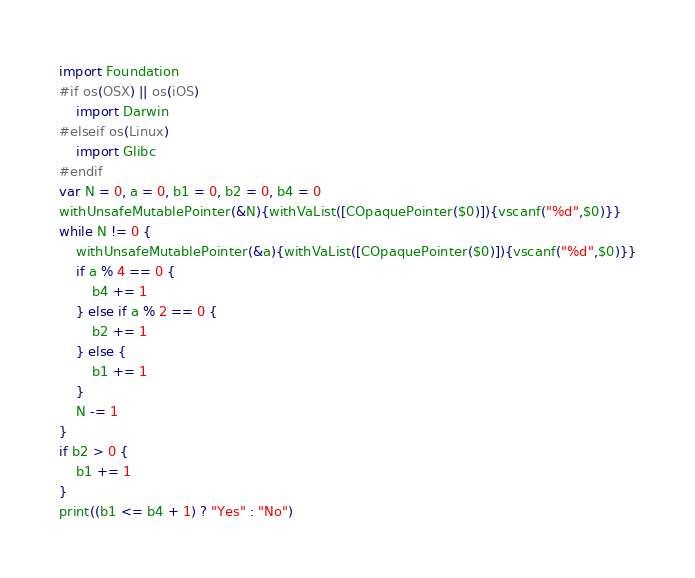<code> <loc_0><loc_0><loc_500><loc_500><_Swift_>import Foundation
#if os(OSX) || os(iOS)
    import Darwin
#elseif os(Linux)
    import Glibc
#endif
var N = 0, a = 0, b1 = 0, b2 = 0, b4 = 0
withUnsafeMutablePointer(&N){withVaList([COpaquePointer($0)]){vscanf("%d",$0)}}
while N != 0 {
    withUnsafeMutablePointer(&a){withVaList([COpaquePointer($0)]){vscanf("%d",$0)}}
    if a % 4 == 0 {
        b4 += 1
    } else if a % 2 == 0 {
        b2 += 1
    } else {
        b1 += 1
    }
    N -= 1
}
if b2 > 0 {
    b1 += 1
}
print((b1 <= b4 + 1) ? "Yes" : "No")</code> 